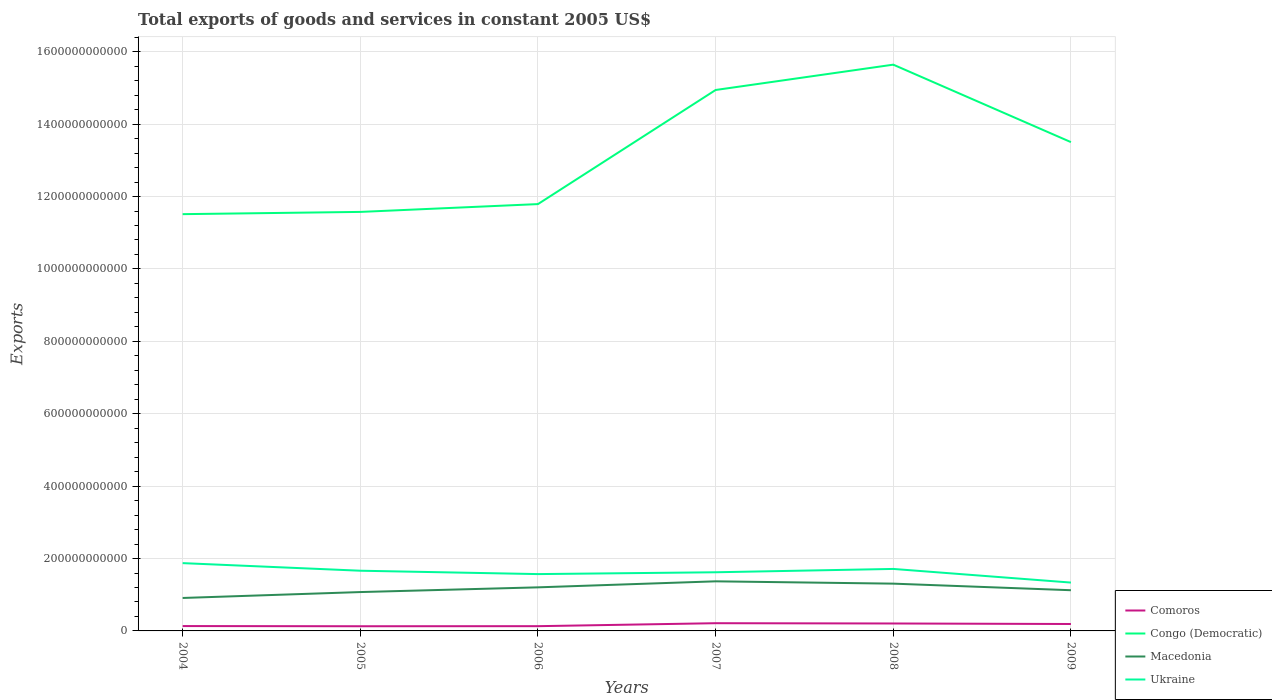How many different coloured lines are there?
Keep it short and to the point. 4. Does the line corresponding to Macedonia intersect with the line corresponding to Comoros?
Provide a short and direct response. No. Across all years, what is the maximum total exports of goods and services in Congo (Democratic)?
Your answer should be very brief. 1.15e+12. In which year was the total exports of goods and services in Ukraine maximum?
Provide a short and direct response. 2009. What is the total total exports of goods and services in Congo (Democratic) in the graph?
Offer a terse response. -1.99e+11. What is the difference between the highest and the second highest total exports of goods and services in Congo (Democratic)?
Give a very brief answer. 4.13e+11. How many lines are there?
Keep it short and to the point. 4. How many years are there in the graph?
Offer a terse response. 6. What is the difference between two consecutive major ticks on the Y-axis?
Offer a very short reply. 2.00e+11. Does the graph contain any zero values?
Provide a succinct answer. No. Where does the legend appear in the graph?
Give a very brief answer. Bottom right. How many legend labels are there?
Provide a short and direct response. 4. How are the legend labels stacked?
Provide a short and direct response. Vertical. What is the title of the graph?
Your answer should be very brief. Total exports of goods and services in constant 2005 US$. What is the label or title of the Y-axis?
Give a very brief answer. Exports. What is the Exports in Comoros in 2004?
Offer a very short reply. 1.34e+1. What is the Exports of Congo (Democratic) in 2004?
Your answer should be very brief. 1.15e+12. What is the Exports of Macedonia in 2004?
Offer a very short reply. 9.10e+1. What is the Exports in Ukraine in 2004?
Your answer should be very brief. 1.87e+11. What is the Exports of Comoros in 2005?
Make the answer very short. 1.29e+1. What is the Exports in Congo (Democratic) in 2005?
Ensure brevity in your answer.  1.16e+12. What is the Exports of Macedonia in 2005?
Offer a terse response. 1.07e+11. What is the Exports of Ukraine in 2005?
Make the answer very short. 1.66e+11. What is the Exports in Comoros in 2006?
Your answer should be compact. 1.31e+1. What is the Exports in Congo (Democratic) in 2006?
Your answer should be compact. 1.18e+12. What is the Exports of Macedonia in 2006?
Your answer should be compact. 1.20e+11. What is the Exports in Ukraine in 2006?
Provide a succinct answer. 1.57e+11. What is the Exports in Comoros in 2007?
Keep it short and to the point. 2.13e+1. What is the Exports in Congo (Democratic) in 2007?
Provide a succinct answer. 1.49e+12. What is the Exports of Macedonia in 2007?
Offer a terse response. 1.37e+11. What is the Exports of Ukraine in 2007?
Make the answer very short. 1.62e+11. What is the Exports in Comoros in 2008?
Your answer should be very brief. 2.06e+1. What is the Exports of Congo (Democratic) in 2008?
Ensure brevity in your answer.  1.56e+12. What is the Exports of Macedonia in 2008?
Offer a terse response. 1.31e+11. What is the Exports of Ukraine in 2008?
Keep it short and to the point. 1.71e+11. What is the Exports of Comoros in 2009?
Ensure brevity in your answer.  1.91e+1. What is the Exports in Congo (Democratic) in 2009?
Make the answer very short. 1.35e+12. What is the Exports in Macedonia in 2009?
Make the answer very short. 1.12e+11. What is the Exports in Ukraine in 2009?
Make the answer very short. 1.34e+11. Across all years, what is the maximum Exports in Comoros?
Keep it short and to the point. 2.13e+1. Across all years, what is the maximum Exports of Congo (Democratic)?
Your response must be concise. 1.56e+12. Across all years, what is the maximum Exports in Macedonia?
Keep it short and to the point. 1.37e+11. Across all years, what is the maximum Exports of Ukraine?
Offer a terse response. 1.87e+11. Across all years, what is the minimum Exports of Comoros?
Ensure brevity in your answer.  1.29e+1. Across all years, what is the minimum Exports in Congo (Democratic)?
Offer a very short reply. 1.15e+12. Across all years, what is the minimum Exports in Macedonia?
Your response must be concise. 9.10e+1. Across all years, what is the minimum Exports of Ukraine?
Ensure brevity in your answer.  1.34e+11. What is the total Exports of Comoros in the graph?
Keep it short and to the point. 1.00e+11. What is the total Exports in Congo (Democratic) in the graph?
Provide a succinct answer. 7.90e+12. What is the total Exports of Macedonia in the graph?
Make the answer very short. 6.99e+11. What is the total Exports in Ukraine in the graph?
Offer a very short reply. 9.77e+11. What is the difference between the Exports of Comoros in 2004 and that in 2005?
Provide a short and direct response. 5.22e+08. What is the difference between the Exports of Congo (Democratic) in 2004 and that in 2005?
Keep it short and to the point. -6.20e+09. What is the difference between the Exports in Macedonia in 2004 and that in 2005?
Your answer should be compact. -1.63e+1. What is the difference between the Exports of Ukraine in 2004 and that in 2005?
Ensure brevity in your answer.  2.10e+1. What is the difference between the Exports in Comoros in 2004 and that in 2006?
Your response must be concise. 2.98e+08. What is the difference between the Exports in Congo (Democratic) in 2004 and that in 2006?
Your answer should be compact. -2.78e+1. What is the difference between the Exports in Macedonia in 2004 and that in 2006?
Provide a succinct answer. -2.93e+1. What is the difference between the Exports in Ukraine in 2004 and that in 2006?
Your response must be concise. 3.03e+1. What is the difference between the Exports of Comoros in 2004 and that in 2007?
Make the answer very short. -7.88e+09. What is the difference between the Exports of Congo (Democratic) in 2004 and that in 2007?
Keep it short and to the point. -3.43e+11. What is the difference between the Exports in Macedonia in 2004 and that in 2007?
Provide a succinct answer. -4.60e+1. What is the difference between the Exports of Ukraine in 2004 and that in 2007?
Ensure brevity in your answer.  2.53e+1. What is the difference between the Exports in Comoros in 2004 and that in 2008?
Provide a succinct answer. -7.12e+09. What is the difference between the Exports in Congo (Democratic) in 2004 and that in 2008?
Give a very brief answer. -4.13e+11. What is the difference between the Exports in Macedonia in 2004 and that in 2008?
Ensure brevity in your answer.  -3.96e+1. What is the difference between the Exports in Ukraine in 2004 and that in 2008?
Your answer should be compact. 1.60e+1. What is the difference between the Exports of Comoros in 2004 and that in 2009?
Offer a very short reply. -5.71e+09. What is the difference between the Exports in Congo (Democratic) in 2004 and that in 2009?
Provide a succinct answer. -1.99e+11. What is the difference between the Exports in Macedonia in 2004 and that in 2009?
Give a very brief answer. -2.14e+1. What is the difference between the Exports in Ukraine in 2004 and that in 2009?
Provide a short and direct response. 5.37e+1. What is the difference between the Exports in Comoros in 2005 and that in 2006?
Offer a terse response. -2.24e+08. What is the difference between the Exports of Congo (Democratic) in 2005 and that in 2006?
Provide a succinct answer. -2.16e+1. What is the difference between the Exports in Macedonia in 2005 and that in 2006?
Provide a succinct answer. -1.30e+1. What is the difference between the Exports of Ukraine in 2005 and that in 2006?
Your answer should be very brief. 9.31e+09. What is the difference between the Exports of Comoros in 2005 and that in 2007?
Offer a very short reply. -8.40e+09. What is the difference between the Exports of Congo (Democratic) in 2005 and that in 2007?
Provide a short and direct response. -3.37e+11. What is the difference between the Exports of Macedonia in 2005 and that in 2007?
Make the answer very short. -2.96e+1. What is the difference between the Exports in Ukraine in 2005 and that in 2007?
Give a very brief answer. 4.29e+09. What is the difference between the Exports of Comoros in 2005 and that in 2008?
Ensure brevity in your answer.  -7.65e+09. What is the difference between the Exports of Congo (Democratic) in 2005 and that in 2008?
Give a very brief answer. -4.07e+11. What is the difference between the Exports of Macedonia in 2005 and that in 2008?
Give a very brief answer. -2.32e+1. What is the difference between the Exports in Ukraine in 2005 and that in 2008?
Keep it short and to the point. -4.95e+09. What is the difference between the Exports in Comoros in 2005 and that in 2009?
Keep it short and to the point. -6.23e+09. What is the difference between the Exports in Congo (Democratic) in 2005 and that in 2009?
Provide a short and direct response. -1.93e+11. What is the difference between the Exports of Macedonia in 2005 and that in 2009?
Make the answer very short. -5.09e+09. What is the difference between the Exports in Ukraine in 2005 and that in 2009?
Offer a very short reply. 3.27e+1. What is the difference between the Exports of Comoros in 2006 and that in 2007?
Ensure brevity in your answer.  -8.17e+09. What is the difference between the Exports in Congo (Democratic) in 2006 and that in 2007?
Provide a succinct answer. -3.15e+11. What is the difference between the Exports in Macedonia in 2006 and that in 2007?
Your response must be concise. -1.66e+1. What is the difference between the Exports of Ukraine in 2006 and that in 2007?
Make the answer very short. -5.02e+09. What is the difference between the Exports in Comoros in 2006 and that in 2008?
Make the answer very short. -7.42e+09. What is the difference between the Exports in Congo (Democratic) in 2006 and that in 2008?
Your answer should be compact. -3.85e+11. What is the difference between the Exports in Macedonia in 2006 and that in 2008?
Your answer should be very brief. -1.02e+1. What is the difference between the Exports in Ukraine in 2006 and that in 2008?
Give a very brief answer. -1.43e+1. What is the difference between the Exports in Comoros in 2006 and that in 2009?
Your answer should be very brief. -6.00e+09. What is the difference between the Exports in Congo (Democratic) in 2006 and that in 2009?
Offer a terse response. -1.71e+11. What is the difference between the Exports of Macedonia in 2006 and that in 2009?
Provide a succinct answer. 7.93e+09. What is the difference between the Exports of Ukraine in 2006 and that in 2009?
Provide a succinct answer. 2.34e+1. What is the difference between the Exports of Comoros in 2007 and that in 2008?
Give a very brief answer. 7.52e+08. What is the difference between the Exports in Congo (Democratic) in 2007 and that in 2008?
Offer a terse response. -7.00e+1. What is the difference between the Exports of Macedonia in 2007 and that in 2008?
Offer a very short reply. 6.40e+09. What is the difference between the Exports of Ukraine in 2007 and that in 2008?
Provide a succinct answer. -9.23e+09. What is the difference between the Exports in Comoros in 2007 and that in 2009?
Ensure brevity in your answer.  2.17e+09. What is the difference between the Exports of Congo (Democratic) in 2007 and that in 2009?
Give a very brief answer. 1.44e+11. What is the difference between the Exports in Macedonia in 2007 and that in 2009?
Offer a very short reply. 2.45e+1. What is the difference between the Exports in Ukraine in 2007 and that in 2009?
Offer a very short reply. 2.84e+1. What is the difference between the Exports of Comoros in 2008 and that in 2009?
Provide a succinct answer. 1.42e+09. What is the difference between the Exports in Congo (Democratic) in 2008 and that in 2009?
Give a very brief answer. 2.14e+11. What is the difference between the Exports in Macedonia in 2008 and that in 2009?
Ensure brevity in your answer.  1.81e+1. What is the difference between the Exports in Ukraine in 2008 and that in 2009?
Give a very brief answer. 3.77e+1. What is the difference between the Exports of Comoros in 2004 and the Exports of Congo (Democratic) in 2005?
Make the answer very short. -1.14e+12. What is the difference between the Exports of Comoros in 2004 and the Exports of Macedonia in 2005?
Make the answer very short. -9.39e+1. What is the difference between the Exports of Comoros in 2004 and the Exports of Ukraine in 2005?
Make the answer very short. -1.53e+11. What is the difference between the Exports of Congo (Democratic) in 2004 and the Exports of Macedonia in 2005?
Provide a short and direct response. 1.04e+12. What is the difference between the Exports of Congo (Democratic) in 2004 and the Exports of Ukraine in 2005?
Provide a short and direct response. 9.85e+11. What is the difference between the Exports of Macedonia in 2004 and the Exports of Ukraine in 2005?
Provide a short and direct response. -7.53e+1. What is the difference between the Exports of Comoros in 2004 and the Exports of Congo (Democratic) in 2006?
Provide a short and direct response. -1.17e+12. What is the difference between the Exports in Comoros in 2004 and the Exports in Macedonia in 2006?
Give a very brief answer. -1.07e+11. What is the difference between the Exports of Comoros in 2004 and the Exports of Ukraine in 2006?
Your response must be concise. -1.44e+11. What is the difference between the Exports in Congo (Democratic) in 2004 and the Exports in Macedonia in 2006?
Ensure brevity in your answer.  1.03e+12. What is the difference between the Exports of Congo (Democratic) in 2004 and the Exports of Ukraine in 2006?
Your answer should be compact. 9.94e+11. What is the difference between the Exports in Macedonia in 2004 and the Exports in Ukraine in 2006?
Make the answer very short. -6.60e+1. What is the difference between the Exports in Comoros in 2004 and the Exports in Congo (Democratic) in 2007?
Provide a succinct answer. -1.48e+12. What is the difference between the Exports in Comoros in 2004 and the Exports in Macedonia in 2007?
Offer a very short reply. -1.24e+11. What is the difference between the Exports of Comoros in 2004 and the Exports of Ukraine in 2007?
Keep it short and to the point. -1.49e+11. What is the difference between the Exports in Congo (Democratic) in 2004 and the Exports in Macedonia in 2007?
Keep it short and to the point. 1.01e+12. What is the difference between the Exports in Congo (Democratic) in 2004 and the Exports in Ukraine in 2007?
Provide a succinct answer. 9.89e+11. What is the difference between the Exports of Macedonia in 2004 and the Exports of Ukraine in 2007?
Ensure brevity in your answer.  -7.10e+1. What is the difference between the Exports in Comoros in 2004 and the Exports in Congo (Democratic) in 2008?
Offer a very short reply. -1.55e+12. What is the difference between the Exports of Comoros in 2004 and the Exports of Macedonia in 2008?
Provide a short and direct response. -1.17e+11. What is the difference between the Exports of Comoros in 2004 and the Exports of Ukraine in 2008?
Offer a terse response. -1.58e+11. What is the difference between the Exports of Congo (Democratic) in 2004 and the Exports of Macedonia in 2008?
Provide a succinct answer. 1.02e+12. What is the difference between the Exports in Congo (Democratic) in 2004 and the Exports in Ukraine in 2008?
Make the answer very short. 9.80e+11. What is the difference between the Exports in Macedonia in 2004 and the Exports in Ukraine in 2008?
Your answer should be very brief. -8.02e+1. What is the difference between the Exports in Comoros in 2004 and the Exports in Congo (Democratic) in 2009?
Your answer should be compact. -1.34e+12. What is the difference between the Exports in Comoros in 2004 and the Exports in Macedonia in 2009?
Offer a terse response. -9.90e+1. What is the difference between the Exports of Comoros in 2004 and the Exports of Ukraine in 2009?
Provide a short and direct response. -1.20e+11. What is the difference between the Exports of Congo (Democratic) in 2004 and the Exports of Macedonia in 2009?
Provide a short and direct response. 1.04e+12. What is the difference between the Exports in Congo (Democratic) in 2004 and the Exports in Ukraine in 2009?
Make the answer very short. 1.02e+12. What is the difference between the Exports in Macedonia in 2004 and the Exports in Ukraine in 2009?
Give a very brief answer. -4.25e+1. What is the difference between the Exports of Comoros in 2005 and the Exports of Congo (Democratic) in 2006?
Make the answer very short. -1.17e+12. What is the difference between the Exports of Comoros in 2005 and the Exports of Macedonia in 2006?
Make the answer very short. -1.07e+11. What is the difference between the Exports in Comoros in 2005 and the Exports in Ukraine in 2006?
Your answer should be compact. -1.44e+11. What is the difference between the Exports of Congo (Democratic) in 2005 and the Exports of Macedonia in 2006?
Offer a terse response. 1.04e+12. What is the difference between the Exports of Congo (Democratic) in 2005 and the Exports of Ukraine in 2006?
Offer a terse response. 1.00e+12. What is the difference between the Exports of Macedonia in 2005 and the Exports of Ukraine in 2006?
Your answer should be very brief. -4.96e+1. What is the difference between the Exports in Comoros in 2005 and the Exports in Congo (Democratic) in 2007?
Your response must be concise. -1.48e+12. What is the difference between the Exports of Comoros in 2005 and the Exports of Macedonia in 2007?
Keep it short and to the point. -1.24e+11. What is the difference between the Exports of Comoros in 2005 and the Exports of Ukraine in 2007?
Make the answer very short. -1.49e+11. What is the difference between the Exports in Congo (Democratic) in 2005 and the Exports in Macedonia in 2007?
Keep it short and to the point. 1.02e+12. What is the difference between the Exports in Congo (Democratic) in 2005 and the Exports in Ukraine in 2007?
Ensure brevity in your answer.  9.95e+11. What is the difference between the Exports of Macedonia in 2005 and the Exports of Ukraine in 2007?
Give a very brief answer. -5.47e+1. What is the difference between the Exports of Comoros in 2005 and the Exports of Congo (Democratic) in 2008?
Provide a succinct answer. -1.55e+12. What is the difference between the Exports of Comoros in 2005 and the Exports of Macedonia in 2008?
Your response must be concise. -1.18e+11. What is the difference between the Exports of Comoros in 2005 and the Exports of Ukraine in 2008?
Give a very brief answer. -1.58e+11. What is the difference between the Exports of Congo (Democratic) in 2005 and the Exports of Macedonia in 2008?
Your answer should be very brief. 1.03e+12. What is the difference between the Exports of Congo (Democratic) in 2005 and the Exports of Ukraine in 2008?
Your answer should be very brief. 9.86e+11. What is the difference between the Exports in Macedonia in 2005 and the Exports in Ukraine in 2008?
Offer a very short reply. -6.39e+1. What is the difference between the Exports in Comoros in 2005 and the Exports in Congo (Democratic) in 2009?
Ensure brevity in your answer.  -1.34e+12. What is the difference between the Exports of Comoros in 2005 and the Exports of Macedonia in 2009?
Keep it short and to the point. -9.95e+1. What is the difference between the Exports in Comoros in 2005 and the Exports in Ukraine in 2009?
Provide a short and direct response. -1.21e+11. What is the difference between the Exports of Congo (Democratic) in 2005 and the Exports of Macedonia in 2009?
Keep it short and to the point. 1.05e+12. What is the difference between the Exports in Congo (Democratic) in 2005 and the Exports in Ukraine in 2009?
Give a very brief answer. 1.02e+12. What is the difference between the Exports of Macedonia in 2005 and the Exports of Ukraine in 2009?
Offer a terse response. -2.62e+1. What is the difference between the Exports of Comoros in 2006 and the Exports of Congo (Democratic) in 2007?
Give a very brief answer. -1.48e+12. What is the difference between the Exports in Comoros in 2006 and the Exports in Macedonia in 2007?
Provide a short and direct response. -1.24e+11. What is the difference between the Exports in Comoros in 2006 and the Exports in Ukraine in 2007?
Make the answer very short. -1.49e+11. What is the difference between the Exports in Congo (Democratic) in 2006 and the Exports in Macedonia in 2007?
Keep it short and to the point. 1.04e+12. What is the difference between the Exports in Congo (Democratic) in 2006 and the Exports in Ukraine in 2007?
Offer a terse response. 1.02e+12. What is the difference between the Exports of Macedonia in 2006 and the Exports of Ukraine in 2007?
Give a very brief answer. -4.16e+1. What is the difference between the Exports in Comoros in 2006 and the Exports in Congo (Democratic) in 2008?
Make the answer very short. -1.55e+12. What is the difference between the Exports of Comoros in 2006 and the Exports of Macedonia in 2008?
Keep it short and to the point. -1.17e+11. What is the difference between the Exports in Comoros in 2006 and the Exports in Ukraine in 2008?
Give a very brief answer. -1.58e+11. What is the difference between the Exports in Congo (Democratic) in 2006 and the Exports in Macedonia in 2008?
Give a very brief answer. 1.05e+12. What is the difference between the Exports of Congo (Democratic) in 2006 and the Exports of Ukraine in 2008?
Keep it short and to the point. 1.01e+12. What is the difference between the Exports in Macedonia in 2006 and the Exports in Ukraine in 2008?
Provide a succinct answer. -5.09e+1. What is the difference between the Exports in Comoros in 2006 and the Exports in Congo (Democratic) in 2009?
Give a very brief answer. -1.34e+12. What is the difference between the Exports in Comoros in 2006 and the Exports in Macedonia in 2009?
Make the answer very short. -9.93e+1. What is the difference between the Exports of Comoros in 2006 and the Exports of Ukraine in 2009?
Provide a succinct answer. -1.20e+11. What is the difference between the Exports of Congo (Democratic) in 2006 and the Exports of Macedonia in 2009?
Provide a short and direct response. 1.07e+12. What is the difference between the Exports of Congo (Democratic) in 2006 and the Exports of Ukraine in 2009?
Ensure brevity in your answer.  1.05e+12. What is the difference between the Exports in Macedonia in 2006 and the Exports in Ukraine in 2009?
Your response must be concise. -1.32e+1. What is the difference between the Exports in Comoros in 2007 and the Exports in Congo (Democratic) in 2008?
Your response must be concise. -1.54e+12. What is the difference between the Exports of Comoros in 2007 and the Exports of Macedonia in 2008?
Provide a short and direct response. -1.09e+11. What is the difference between the Exports in Comoros in 2007 and the Exports in Ukraine in 2008?
Make the answer very short. -1.50e+11. What is the difference between the Exports in Congo (Democratic) in 2007 and the Exports in Macedonia in 2008?
Ensure brevity in your answer.  1.36e+12. What is the difference between the Exports of Congo (Democratic) in 2007 and the Exports of Ukraine in 2008?
Offer a very short reply. 1.32e+12. What is the difference between the Exports in Macedonia in 2007 and the Exports in Ukraine in 2008?
Offer a very short reply. -3.43e+1. What is the difference between the Exports of Comoros in 2007 and the Exports of Congo (Democratic) in 2009?
Offer a very short reply. -1.33e+12. What is the difference between the Exports in Comoros in 2007 and the Exports in Macedonia in 2009?
Give a very brief answer. -9.11e+1. What is the difference between the Exports of Comoros in 2007 and the Exports of Ukraine in 2009?
Give a very brief answer. -1.12e+11. What is the difference between the Exports in Congo (Democratic) in 2007 and the Exports in Macedonia in 2009?
Make the answer very short. 1.38e+12. What is the difference between the Exports of Congo (Democratic) in 2007 and the Exports of Ukraine in 2009?
Give a very brief answer. 1.36e+12. What is the difference between the Exports of Macedonia in 2007 and the Exports of Ukraine in 2009?
Give a very brief answer. 3.42e+09. What is the difference between the Exports in Comoros in 2008 and the Exports in Congo (Democratic) in 2009?
Offer a terse response. -1.33e+12. What is the difference between the Exports of Comoros in 2008 and the Exports of Macedonia in 2009?
Keep it short and to the point. -9.19e+1. What is the difference between the Exports in Comoros in 2008 and the Exports in Ukraine in 2009?
Offer a very short reply. -1.13e+11. What is the difference between the Exports of Congo (Democratic) in 2008 and the Exports of Macedonia in 2009?
Offer a very short reply. 1.45e+12. What is the difference between the Exports of Congo (Democratic) in 2008 and the Exports of Ukraine in 2009?
Your answer should be compact. 1.43e+12. What is the difference between the Exports of Macedonia in 2008 and the Exports of Ukraine in 2009?
Make the answer very short. -2.98e+09. What is the average Exports of Comoros per year?
Make the answer very short. 1.67e+1. What is the average Exports in Congo (Democratic) per year?
Your answer should be compact. 1.32e+12. What is the average Exports of Macedonia per year?
Your response must be concise. 1.16e+11. What is the average Exports of Ukraine per year?
Make the answer very short. 1.63e+11. In the year 2004, what is the difference between the Exports of Comoros and Exports of Congo (Democratic)?
Give a very brief answer. -1.14e+12. In the year 2004, what is the difference between the Exports of Comoros and Exports of Macedonia?
Offer a very short reply. -7.76e+1. In the year 2004, what is the difference between the Exports of Comoros and Exports of Ukraine?
Give a very brief answer. -1.74e+11. In the year 2004, what is the difference between the Exports of Congo (Democratic) and Exports of Macedonia?
Your response must be concise. 1.06e+12. In the year 2004, what is the difference between the Exports in Congo (Democratic) and Exports in Ukraine?
Provide a short and direct response. 9.64e+11. In the year 2004, what is the difference between the Exports in Macedonia and Exports in Ukraine?
Ensure brevity in your answer.  -9.62e+1. In the year 2005, what is the difference between the Exports of Comoros and Exports of Congo (Democratic)?
Keep it short and to the point. -1.14e+12. In the year 2005, what is the difference between the Exports in Comoros and Exports in Macedonia?
Your answer should be very brief. -9.45e+1. In the year 2005, what is the difference between the Exports in Comoros and Exports in Ukraine?
Offer a terse response. -1.53e+11. In the year 2005, what is the difference between the Exports in Congo (Democratic) and Exports in Macedonia?
Offer a terse response. 1.05e+12. In the year 2005, what is the difference between the Exports in Congo (Democratic) and Exports in Ukraine?
Your answer should be very brief. 9.91e+11. In the year 2005, what is the difference between the Exports in Macedonia and Exports in Ukraine?
Your answer should be compact. -5.89e+1. In the year 2006, what is the difference between the Exports of Comoros and Exports of Congo (Democratic)?
Give a very brief answer. -1.17e+12. In the year 2006, what is the difference between the Exports of Comoros and Exports of Macedonia?
Offer a terse response. -1.07e+11. In the year 2006, what is the difference between the Exports of Comoros and Exports of Ukraine?
Ensure brevity in your answer.  -1.44e+11. In the year 2006, what is the difference between the Exports of Congo (Democratic) and Exports of Macedonia?
Your answer should be very brief. 1.06e+12. In the year 2006, what is the difference between the Exports in Congo (Democratic) and Exports in Ukraine?
Keep it short and to the point. 1.02e+12. In the year 2006, what is the difference between the Exports in Macedonia and Exports in Ukraine?
Ensure brevity in your answer.  -3.66e+1. In the year 2007, what is the difference between the Exports of Comoros and Exports of Congo (Democratic)?
Provide a short and direct response. -1.47e+12. In the year 2007, what is the difference between the Exports in Comoros and Exports in Macedonia?
Offer a terse response. -1.16e+11. In the year 2007, what is the difference between the Exports of Comoros and Exports of Ukraine?
Offer a very short reply. -1.41e+11. In the year 2007, what is the difference between the Exports of Congo (Democratic) and Exports of Macedonia?
Make the answer very short. 1.36e+12. In the year 2007, what is the difference between the Exports in Congo (Democratic) and Exports in Ukraine?
Your answer should be compact. 1.33e+12. In the year 2007, what is the difference between the Exports in Macedonia and Exports in Ukraine?
Keep it short and to the point. -2.50e+1. In the year 2008, what is the difference between the Exports of Comoros and Exports of Congo (Democratic)?
Provide a succinct answer. -1.54e+12. In the year 2008, what is the difference between the Exports in Comoros and Exports in Macedonia?
Provide a succinct answer. -1.10e+11. In the year 2008, what is the difference between the Exports in Comoros and Exports in Ukraine?
Provide a succinct answer. -1.51e+11. In the year 2008, what is the difference between the Exports in Congo (Democratic) and Exports in Macedonia?
Make the answer very short. 1.43e+12. In the year 2008, what is the difference between the Exports in Congo (Democratic) and Exports in Ukraine?
Ensure brevity in your answer.  1.39e+12. In the year 2008, what is the difference between the Exports of Macedonia and Exports of Ukraine?
Provide a succinct answer. -4.07e+1. In the year 2009, what is the difference between the Exports of Comoros and Exports of Congo (Democratic)?
Give a very brief answer. -1.33e+12. In the year 2009, what is the difference between the Exports in Comoros and Exports in Macedonia?
Your answer should be very brief. -9.33e+1. In the year 2009, what is the difference between the Exports in Comoros and Exports in Ukraine?
Give a very brief answer. -1.14e+11. In the year 2009, what is the difference between the Exports of Congo (Democratic) and Exports of Macedonia?
Make the answer very short. 1.24e+12. In the year 2009, what is the difference between the Exports in Congo (Democratic) and Exports in Ukraine?
Your answer should be very brief. 1.22e+12. In the year 2009, what is the difference between the Exports of Macedonia and Exports of Ukraine?
Provide a short and direct response. -2.11e+1. What is the ratio of the Exports of Comoros in 2004 to that in 2005?
Ensure brevity in your answer.  1.04. What is the ratio of the Exports in Congo (Democratic) in 2004 to that in 2005?
Provide a succinct answer. 0.99. What is the ratio of the Exports of Macedonia in 2004 to that in 2005?
Give a very brief answer. 0.85. What is the ratio of the Exports of Ukraine in 2004 to that in 2005?
Make the answer very short. 1.13. What is the ratio of the Exports of Comoros in 2004 to that in 2006?
Your answer should be very brief. 1.02. What is the ratio of the Exports in Congo (Democratic) in 2004 to that in 2006?
Your response must be concise. 0.98. What is the ratio of the Exports in Macedonia in 2004 to that in 2006?
Your answer should be very brief. 0.76. What is the ratio of the Exports in Ukraine in 2004 to that in 2006?
Your answer should be compact. 1.19. What is the ratio of the Exports of Comoros in 2004 to that in 2007?
Provide a succinct answer. 0.63. What is the ratio of the Exports in Congo (Democratic) in 2004 to that in 2007?
Provide a short and direct response. 0.77. What is the ratio of the Exports of Macedonia in 2004 to that in 2007?
Make the answer very short. 0.66. What is the ratio of the Exports in Ukraine in 2004 to that in 2007?
Your response must be concise. 1.16. What is the ratio of the Exports in Comoros in 2004 to that in 2008?
Keep it short and to the point. 0.65. What is the ratio of the Exports of Congo (Democratic) in 2004 to that in 2008?
Your answer should be very brief. 0.74. What is the ratio of the Exports in Macedonia in 2004 to that in 2008?
Your answer should be very brief. 0.7. What is the ratio of the Exports in Ukraine in 2004 to that in 2008?
Give a very brief answer. 1.09. What is the ratio of the Exports in Comoros in 2004 to that in 2009?
Give a very brief answer. 0.7. What is the ratio of the Exports of Congo (Democratic) in 2004 to that in 2009?
Provide a short and direct response. 0.85. What is the ratio of the Exports of Macedonia in 2004 to that in 2009?
Offer a very short reply. 0.81. What is the ratio of the Exports of Ukraine in 2004 to that in 2009?
Keep it short and to the point. 1.4. What is the ratio of the Exports in Comoros in 2005 to that in 2006?
Offer a very short reply. 0.98. What is the ratio of the Exports in Congo (Democratic) in 2005 to that in 2006?
Keep it short and to the point. 0.98. What is the ratio of the Exports in Macedonia in 2005 to that in 2006?
Keep it short and to the point. 0.89. What is the ratio of the Exports of Ukraine in 2005 to that in 2006?
Offer a very short reply. 1.06. What is the ratio of the Exports in Comoros in 2005 to that in 2007?
Provide a succinct answer. 0.61. What is the ratio of the Exports of Congo (Democratic) in 2005 to that in 2007?
Give a very brief answer. 0.77. What is the ratio of the Exports of Macedonia in 2005 to that in 2007?
Provide a succinct answer. 0.78. What is the ratio of the Exports of Ukraine in 2005 to that in 2007?
Your answer should be compact. 1.03. What is the ratio of the Exports of Comoros in 2005 to that in 2008?
Your response must be concise. 0.63. What is the ratio of the Exports in Congo (Democratic) in 2005 to that in 2008?
Ensure brevity in your answer.  0.74. What is the ratio of the Exports in Macedonia in 2005 to that in 2008?
Give a very brief answer. 0.82. What is the ratio of the Exports of Ukraine in 2005 to that in 2008?
Provide a succinct answer. 0.97. What is the ratio of the Exports in Comoros in 2005 to that in 2009?
Ensure brevity in your answer.  0.67. What is the ratio of the Exports in Congo (Democratic) in 2005 to that in 2009?
Ensure brevity in your answer.  0.86. What is the ratio of the Exports in Macedonia in 2005 to that in 2009?
Provide a succinct answer. 0.95. What is the ratio of the Exports in Ukraine in 2005 to that in 2009?
Give a very brief answer. 1.25. What is the ratio of the Exports in Comoros in 2006 to that in 2007?
Offer a very short reply. 0.62. What is the ratio of the Exports of Congo (Democratic) in 2006 to that in 2007?
Ensure brevity in your answer.  0.79. What is the ratio of the Exports in Macedonia in 2006 to that in 2007?
Ensure brevity in your answer.  0.88. What is the ratio of the Exports in Comoros in 2006 to that in 2008?
Give a very brief answer. 0.64. What is the ratio of the Exports of Congo (Democratic) in 2006 to that in 2008?
Offer a very short reply. 0.75. What is the ratio of the Exports of Macedonia in 2006 to that in 2008?
Provide a short and direct response. 0.92. What is the ratio of the Exports of Comoros in 2006 to that in 2009?
Ensure brevity in your answer.  0.69. What is the ratio of the Exports in Congo (Democratic) in 2006 to that in 2009?
Keep it short and to the point. 0.87. What is the ratio of the Exports in Macedonia in 2006 to that in 2009?
Your answer should be very brief. 1.07. What is the ratio of the Exports in Ukraine in 2006 to that in 2009?
Ensure brevity in your answer.  1.18. What is the ratio of the Exports in Comoros in 2007 to that in 2008?
Offer a very short reply. 1.04. What is the ratio of the Exports in Congo (Democratic) in 2007 to that in 2008?
Make the answer very short. 0.96. What is the ratio of the Exports in Macedonia in 2007 to that in 2008?
Provide a succinct answer. 1.05. What is the ratio of the Exports in Ukraine in 2007 to that in 2008?
Make the answer very short. 0.95. What is the ratio of the Exports of Comoros in 2007 to that in 2009?
Ensure brevity in your answer.  1.11. What is the ratio of the Exports in Congo (Democratic) in 2007 to that in 2009?
Provide a succinct answer. 1.11. What is the ratio of the Exports of Macedonia in 2007 to that in 2009?
Your response must be concise. 1.22. What is the ratio of the Exports of Ukraine in 2007 to that in 2009?
Offer a very short reply. 1.21. What is the ratio of the Exports in Comoros in 2008 to that in 2009?
Give a very brief answer. 1.07. What is the ratio of the Exports in Congo (Democratic) in 2008 to that in 2009?
Give a very brief answer. 1.16. What is the ratio of the Exports in Macedonia in 2008 to that in 2009?
Provide a succinct answer. 1.16. What is the ratio of the Exports of Ukraine in 2008 to that in 2009?
Provide a succinct answer. 1.28. What is the difference between the highest and the second highest Exports in Comoros?
Ensure brevity in your answer.  7.52e+08. What is the difference between the highest and the second highest Exports of Congo (Democratic)?
Make the answer very short. 7.00e+1. What is the difference between the highest and the second highest Exports of Macedonia?
Offer a terse response. 6.40e+09. What is the difference between the highest and the second highest Exports of Ukraine?
Your answer should be very brief. 1.60e+1. What is the difference between the highest and the lowest Exports of Comoros?
Keep it short and to the point. 8.40e+09. What is the difference between the highest and the lowest Exports of Congo (Democratic)?
Give a very brief answer. 4.13e+11. What is the difference between the highest and the lowest Exports of Macedonia?
Keep it short and to the point. 4.60e+1. What is the difference between the highest and the lowest Exports of Ukraine?
Make the answer very short. 5.37e+1. 